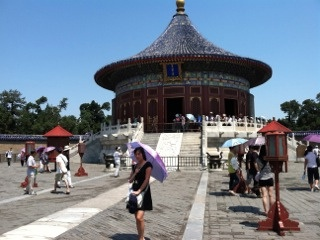Describe the objects in this image and their specific colors. I can see people in gray, black, darkgray, and maroon tones, people in gray, black, and maroon tones, people in gray, black, and darkgray tones, umbrella in gray, purple, lavender, and violet tones, and people in gray, white, darkgray, and black tones in this image. 